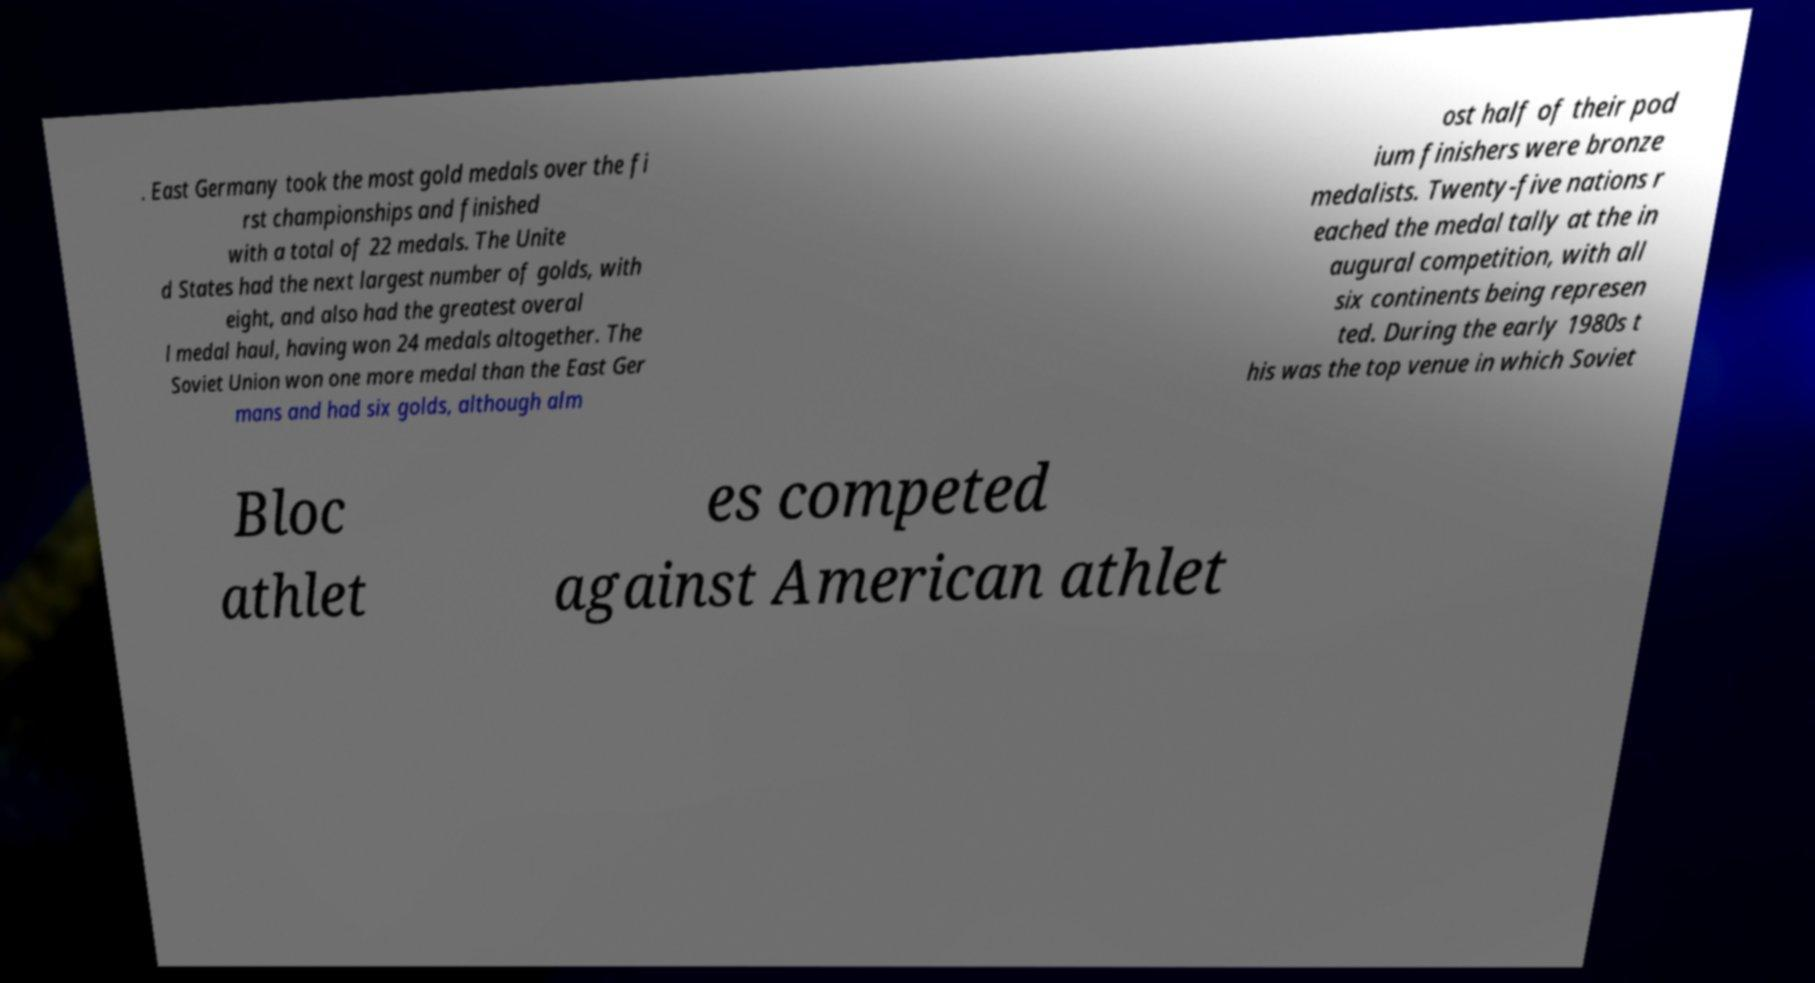For documentation purposes, I need the text within this image transcribed. Could you provide that? . East Germany took the most gold medals over the fi rst championships and finished with a total of 22 medals. The Unite d States had the next largest number of golds, with eight, and also had the greatest overal l medal haul, having won 24 medals altogether. The Soviet Union won one more medal than the East Ger mans and had six golds, although alm ost half of their pod ium finishers were bronze medalists. Twenty-five nations r eached the medal tally at the in augural competition, with all six continents being represen ted. During the early 1980s t his was the top venue in which Soviet Bloc athlet es competed against American athlet 